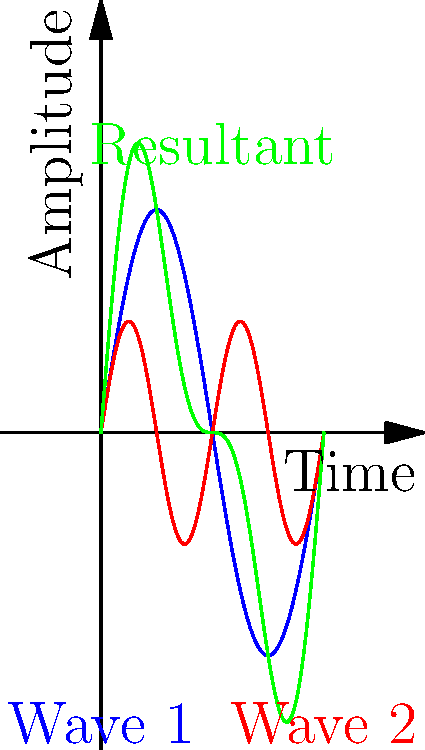In your music production experiments, you're working with sound wave addition. The blue wave represents a fundamental frequency, and the red wave represents its first harmonic (twice the frequency, half the amplitude). What type of sound wave does the green line represent, and how does it relate to the concept of timbre in music? To understand this, let's break it down step-by-step:

1. Wave Components:
   - Blue wave: Fundamental frequency (e.g., 440 Hz for A4)
   - Red wave: First harmonic (e.g., 880 Hz), with half the amplitude

2. Vector Addition:
   The green wave is the result of vector addition of the blue and red waves. At each point in time, the amplitudes of the two waves are added together.

3. Resulting Waveform:
   The green wave shows a more complex pattern than either of its components. It has the same fundamental frequency as the blue wave but with a modified shape.

4. Harmonic Series:
   This combination of a fundamental frequency and its harmonic is part of the harmonic series, which is crucial in music theory and sound production.

5. Timbre:
   Timbre is the quality of a musical note that distinguishes different types of sound production and instruments. It's determined by the presence and strength of harmonics.

6. Relation to Timbre:
   The green wave represents a more complex timbre than either of its components alone. In music production, combining fundamentals with harmonics in various proportions creates different timbres, allowing you to shape the character of the sound.

Therefore, the green wave represents a composite sound wave with a richer timbre, created by the addition of a fundamental frequency and its first harmonic.
Answer: Composite wave with enriched timbre 